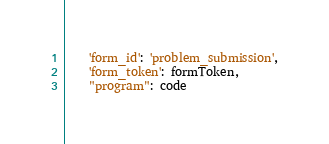Convert code to text. <code><loc_0><loc_0><loc_500><loc_500><_Python_>	'form_id': 'problem_submission',
	'form_token': formToken,
	"program": code</code> 